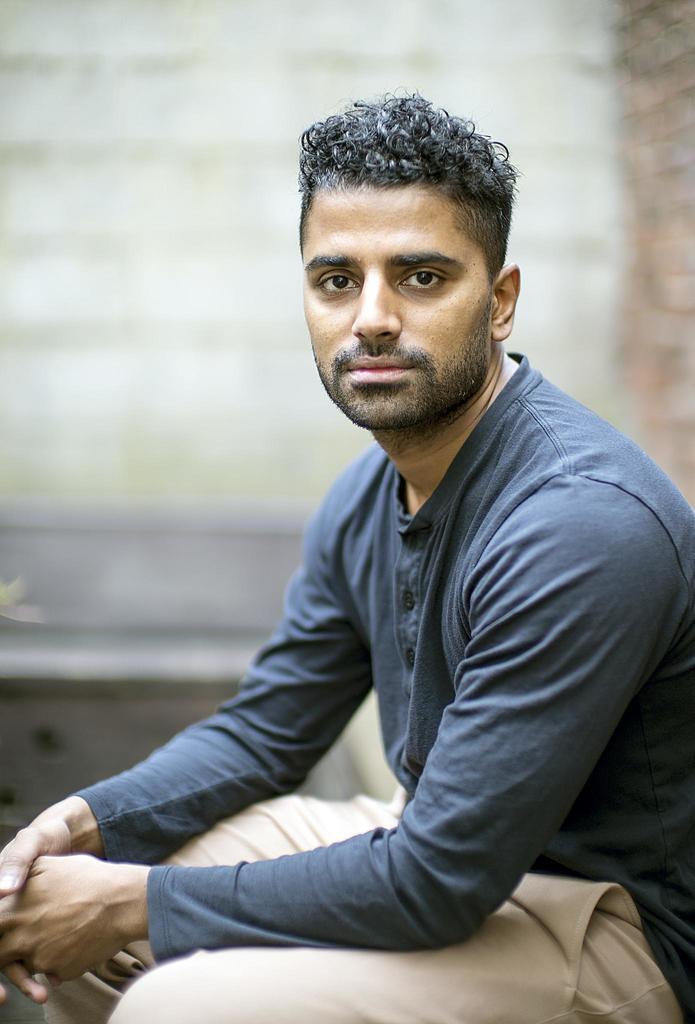Describe this image in one or two sentences. In this image, we can see a person wearing T-shirt and trousers is sitting and the background is blurred. 